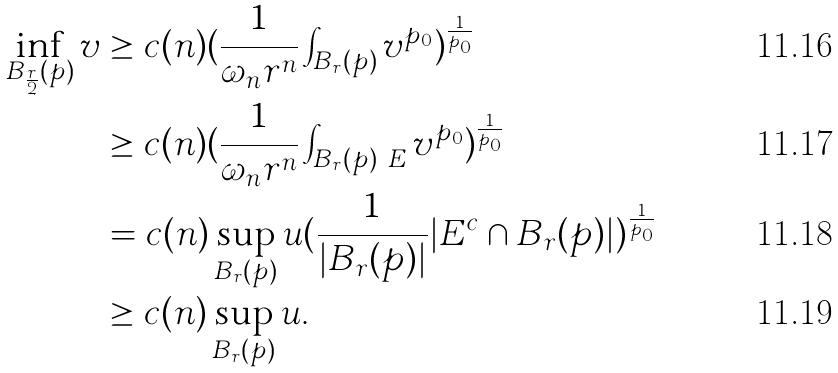Convert formula to latex. <formula><loc_0><loc_0><loc_500><loc_500>\inf _ { B _ { \frac { r } { 2 } } ( p ) } v & \geq c ( n ) ( \frac { 1 } { \omega _ { n } r ^ { n } } \int _ { B _ { r } ( p ) } v ^ { p _ { 0 } } ) ^ { \frac { 1 } { p _ { 0 } } } \\ & \geq c ( n ) ( \frac { 1 } { \omega _ { n } r ^ { n } } \int _ { B _ { r } ( p ) \ E } v ^ { p _ { 0 } } ) ^ { \frac { 1 } { p _ { 0 } } } \\ & = c ( n ) \sup _ { B _ { r } ( p ) } u ( \frac { 1 } { | B _ { r } ( p ) | } | E ^ { c } \cap B _ { r } ( p ) | ) ^ { \frac { 1 } { p _ { 0 } } } \\ & \geq c ( n ) \sup _ { B _ { r } ( p ) } u .</formula> 